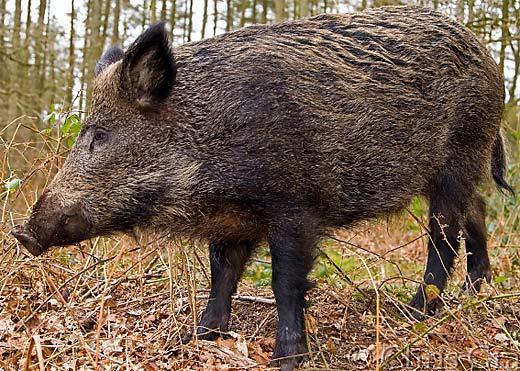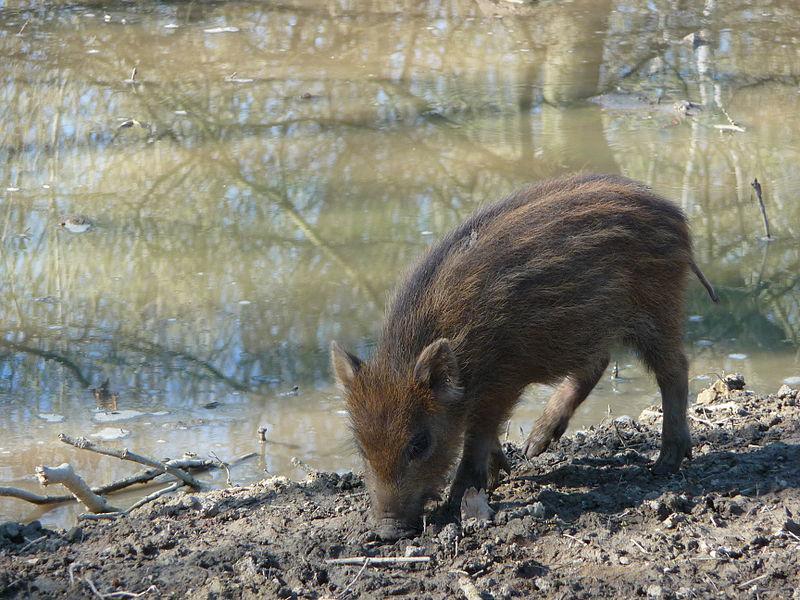The first image is the image on the left, the second image is the image on the right. Assess this claim about the two images: "There are baby boars in the image on the left.". Correct or not? Answer yes or no. No. 